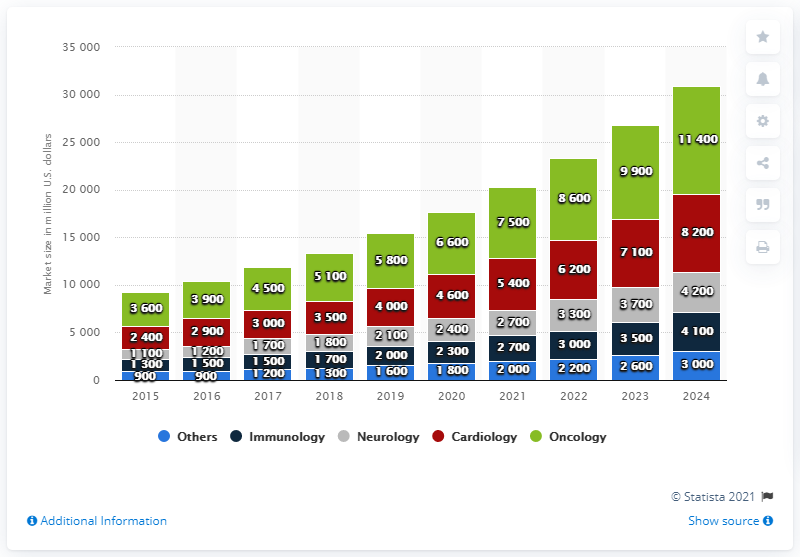List a handful of essential elements in this visual. In the field of oncology, approximately 3,600 dollars were present. 